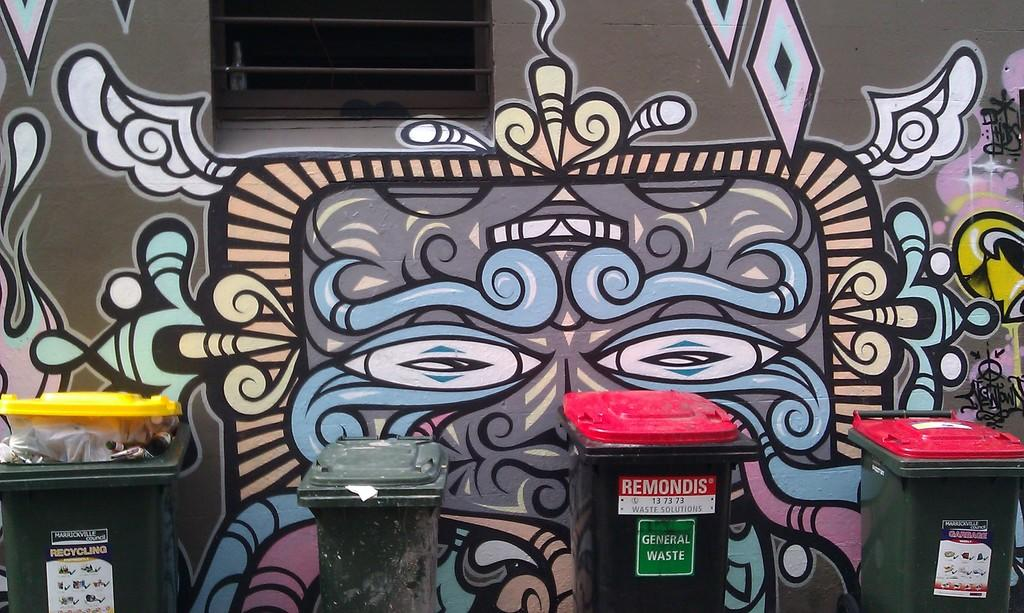<image>
Present a compact description of the photo's key features. A door is marked with a green General Waste sign. 